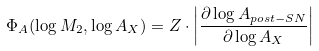<formula> <loc_0><loc_0><loc_500><loc_500>\Phi _ { A } ( \log M _ { 2 } , \log A _ { X } ) = Z \cdot \left | \frac { \partial \log A _ { p o s t - S N } } { \partial \log A _ { X } } \right |</formula> 